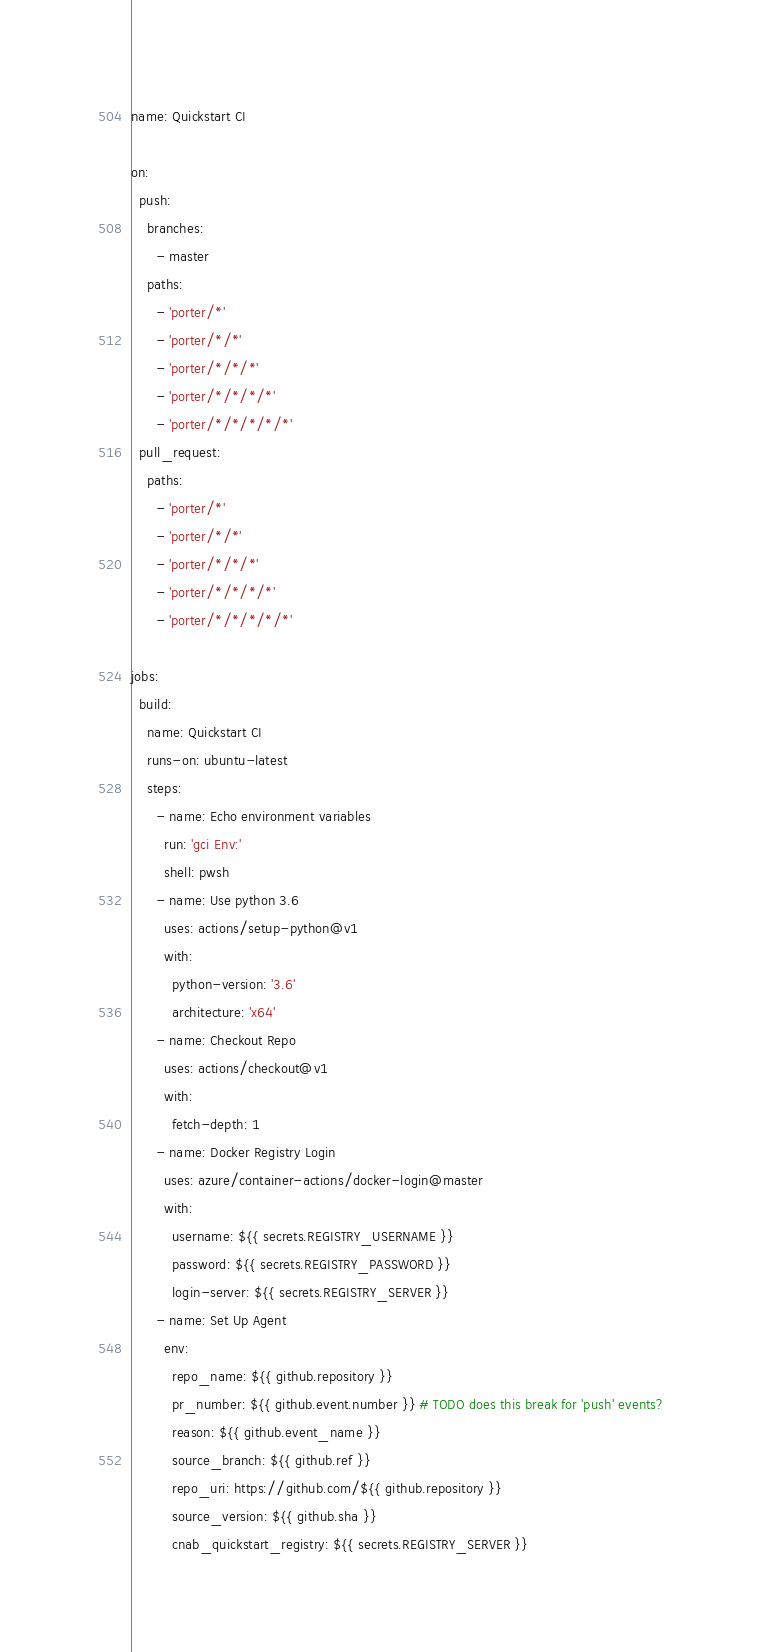Convert code to text. <code><loc_0><loc_0><loc_500><loc_500><_YAML_>name: Quickstart CI

on: 
  push:
    branches: 
      - master
    paths:
      - 'porter/*'
      - 'porter/*/*'
      - 'porter/*/*/*'
      - 'porter/*/*/*/*'
      - 'porter/*/*/*/*/*'
  pull_request:
    paths:
      - 'porter/*'
      - 'porter/*/*'
      - 'porter/*/*/*'
      - 'porter/*/*/*/*'
      - 'porter/*/*/*/*/*'

jobs:
  build:
    name: Quickstart CI
    runs-on: ubuntu-latest
    steps:
      - name: Echo environment variables
        run: 'gci Env:'
        shell: pwsh
      - name: Use python 3.6
        uses: actions/setup-python@v1
        with:
          python-version: '3.6'
          architecture: 'x64'
      - name: Checkout Repo
        uses: actions/checkout@v1
        with:
          fetch-depth: 1
      - name: Docker Registry Login
        uses: azure/container-actions/docker-login@master
        with:
          username: ${{ secrets.REGISTRY_USERNAME }}
          password: ${{ secrets.REGISTRY_PASSWORD }}
          login-server: ${{ secrets.REGISTRY_SERVER }}
      - name: Set Up Agent
        env:
          repo_name: ${{ github.repository }}
          pr_number: ${{ github.event.number }} # TODO does this break for 'push' events?
          reason: ${{ github.event_name }}
          source_branch: ${{ github.ref }}
          repo_uri: https://github.com/${{ github.repository }}
          source_version: ${{ github.sha }}
          cnab_quickstart_registry: ${{ secrets.REGISTRY_SERVER }}</code> 